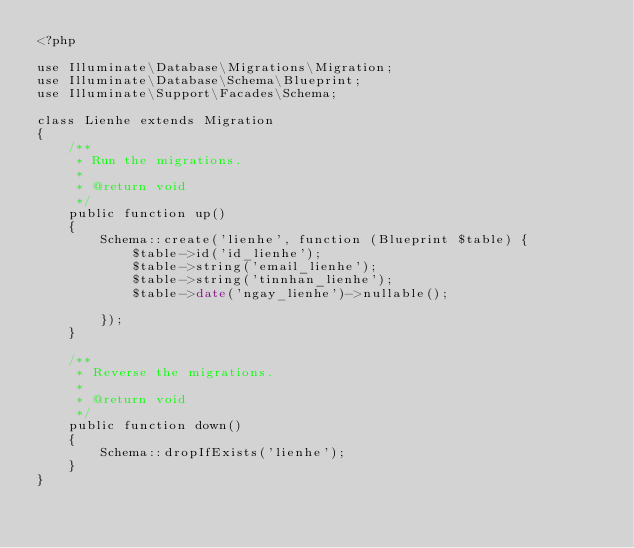Convert code to text. <code><loc_0><loc_0><loc_500><loc_500><_PHP_><?php

use Illuminate\Database\Migrations\Migration;
use Illuminate\Database\Schema\Blueprint;
use Illuminate\Support\Facades\Schema;

class Lienhe extends Migration
{
    /**
     * Run the migrations.
     *
     * @return void
     */
    public function up()
    {
        Schema::create('lienhe', function (Blueprint $table) {
            $table->id('id_lienhe');
            $table->string('email_lienhe');
            $table->string('tinnhan_lienhe');
            $table->date('ngay_lienhe')->nullable();
            
        });
    }

    /**
     * Reverse the migrations.
     *
     * @return void
     */
    public function down()
    {
        Schema::dropIfExists('lienhe');
    }
}
</code> 